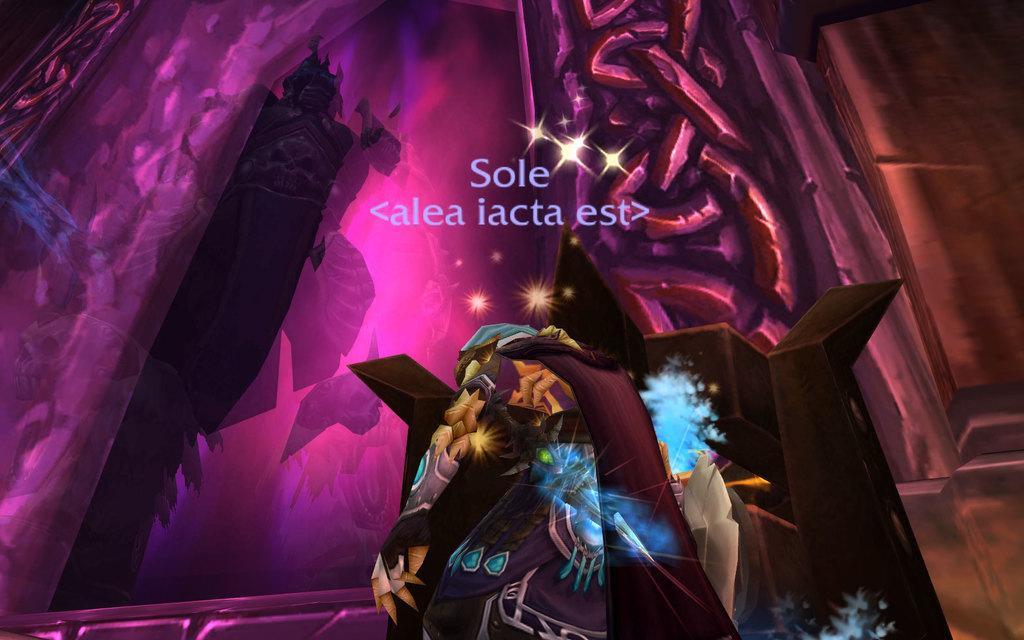Could you give a brief overview of what you see in this image? In the image I can see animation of a person and some other things. I can also see something written on the image. 